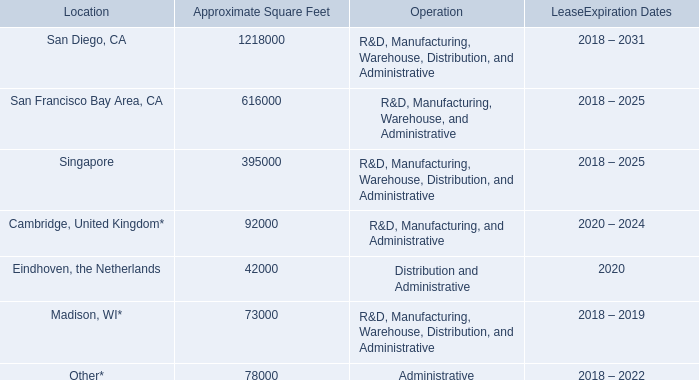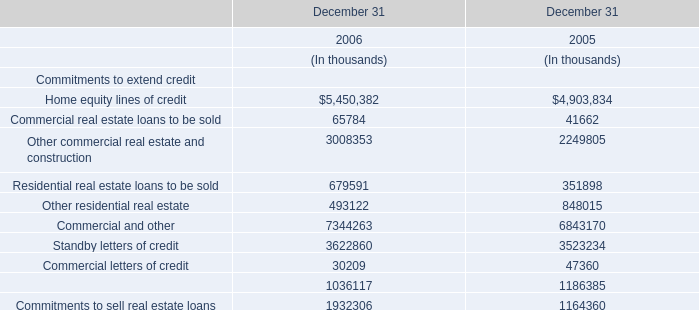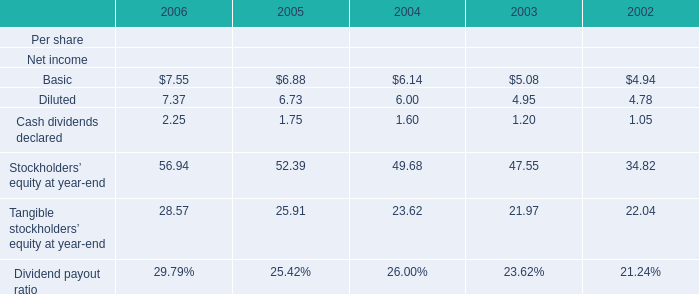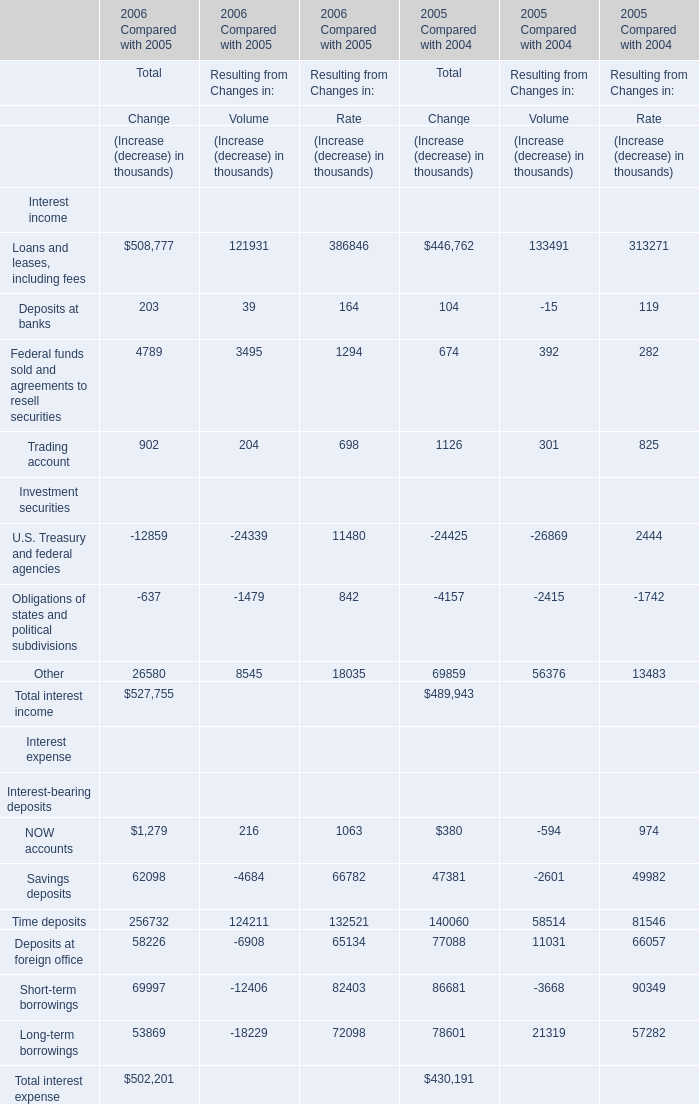in madison wi what was the ratio of the square feet excluded for which the leases do not commence until 2018 as of december 31 , 2017 
Computations: (309000 / 73000)
Answer: 4.23288. 